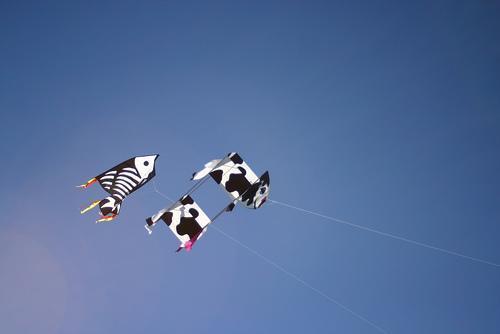What animal pattern is the two piece kite using?
Select the accurate response from the four choices given to answer the question.
Options: Cow, jaguar, zebra, leopard. Cow. 